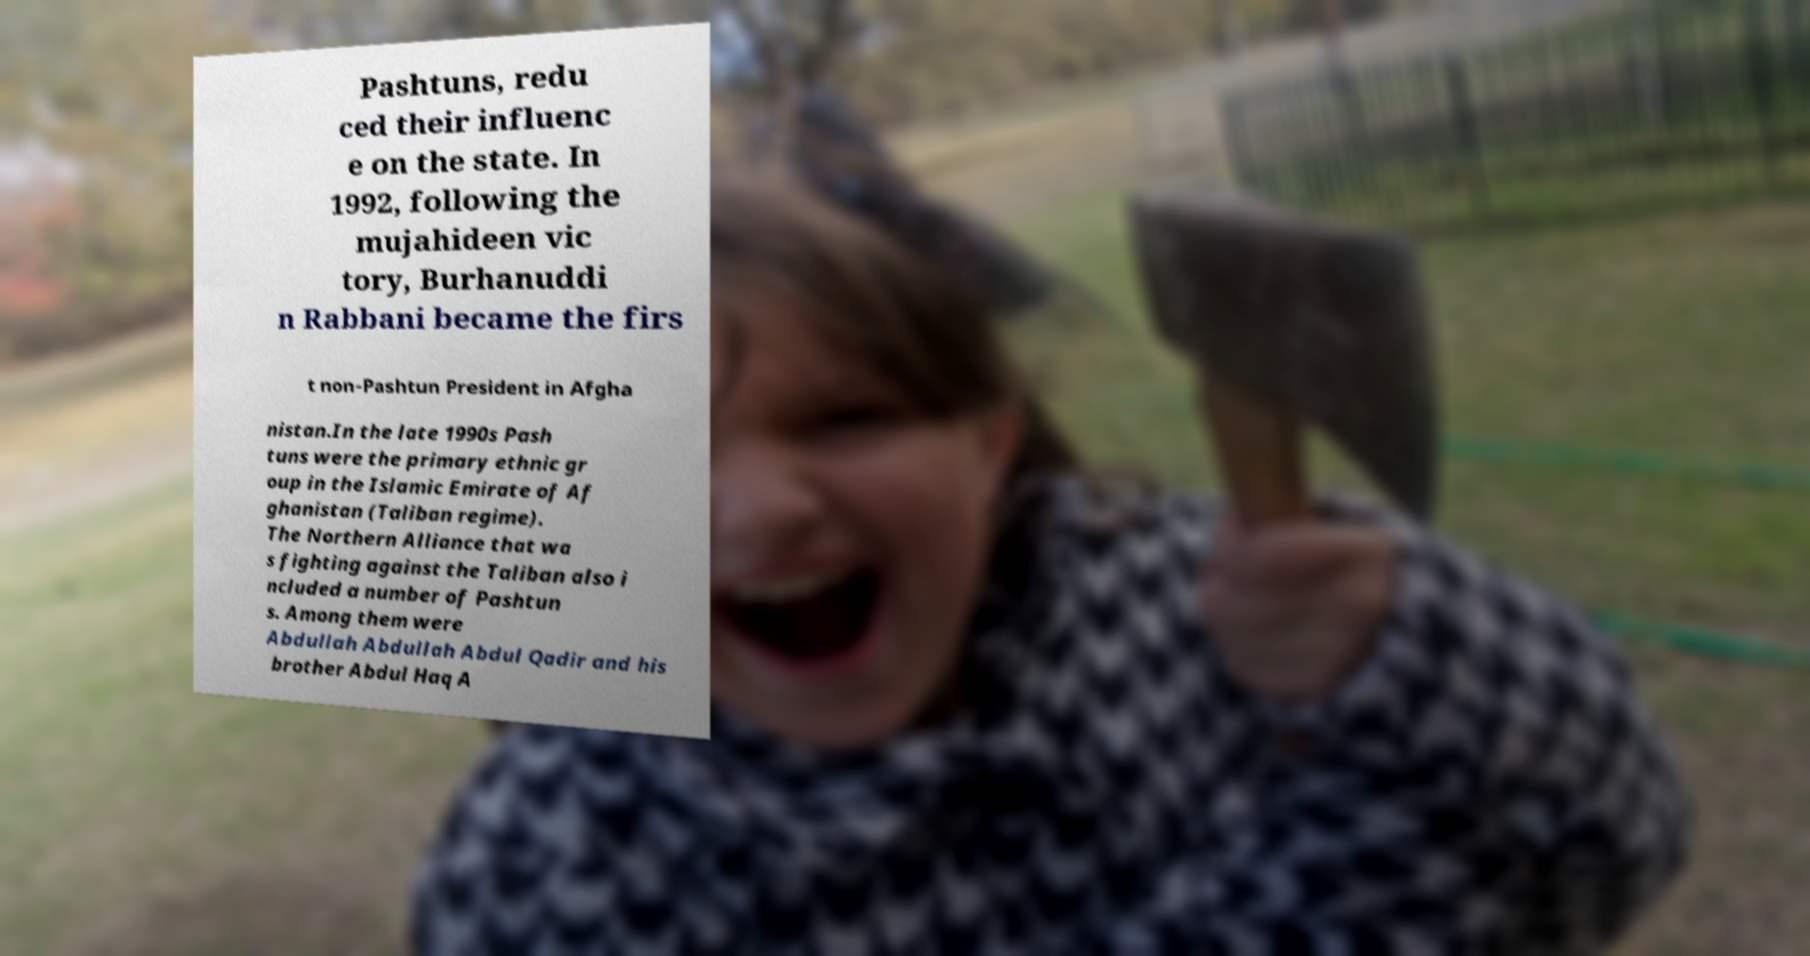Please identify and transcribe the text found in this image. Pashtuns, redu ced their influenc e on the state. In 1992, following the mujahideen vic tory, Burhanuddi n Rabbani became the firs t non-Pashtun President in Afgha nistan.In the late 1990s Pash tuns were the primary ethnic gr oup in the Islamic Emirate of Af ghanistan (Taliban regime). The Northern Alliance that wa s fighting against the Taliban also i ncluded a number of Pashtun s. Among them were Abdullah Abdullah Abdul Qadir and his brother Abdul Haq A 